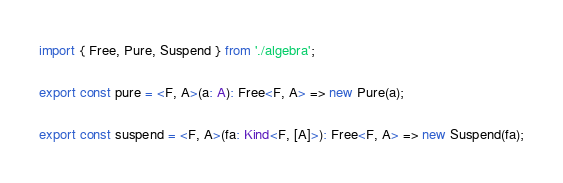<code> <loc_0><loc_0><loc_500><loc_500><_TypeScript_>import { Free, Pure, Suspend } from './algebra';

export const pure = <F, A>(a: A): Free<F, A> => new Pure(a);

export const suspend = <F, A>(fa: Kind<F, [A]>): Free<F, A> => new Suspend(fa);
</code> 